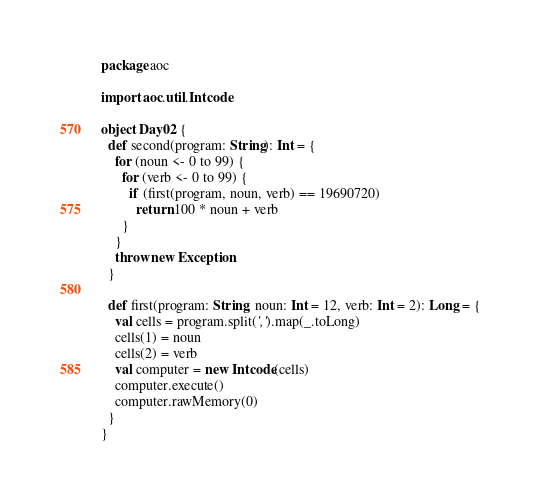Convert code to text. <code><loc_0><loc_0><loc_500><loc_500><_Scala_>package aoc

import aoc.util.Intcode

object Day02 {
  def second(program: String): Int = {
    for (noun <- 0 to 99) {
      for (verb <- 0 to 99) {
        if (first(program, noun, verb) == 19690720)
          return 100 * noun + verb
      }
    }
    throw new Exception
  }

  def first(program: String, noun: Int = 12, verb: Int = 2): Long = {
    val cells = program.split(',').map(_.toLong)
    cells(1) = noun
    cells(2) = verb
    val computer = new Intcode(cells)
    computer.execute()
    computer.rawMemory(0)
  }
}
</code> 